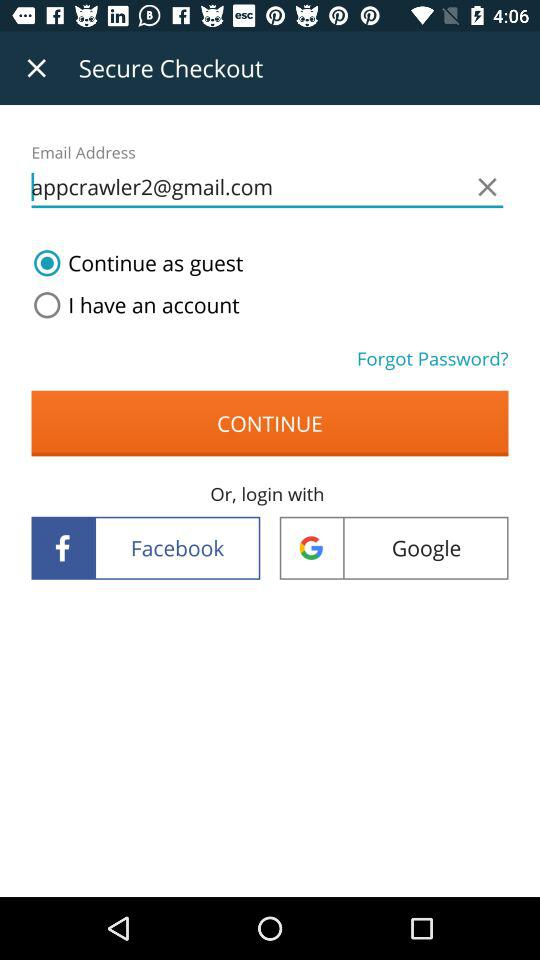What are the login options? You can login with "Facebook" and "Google". 